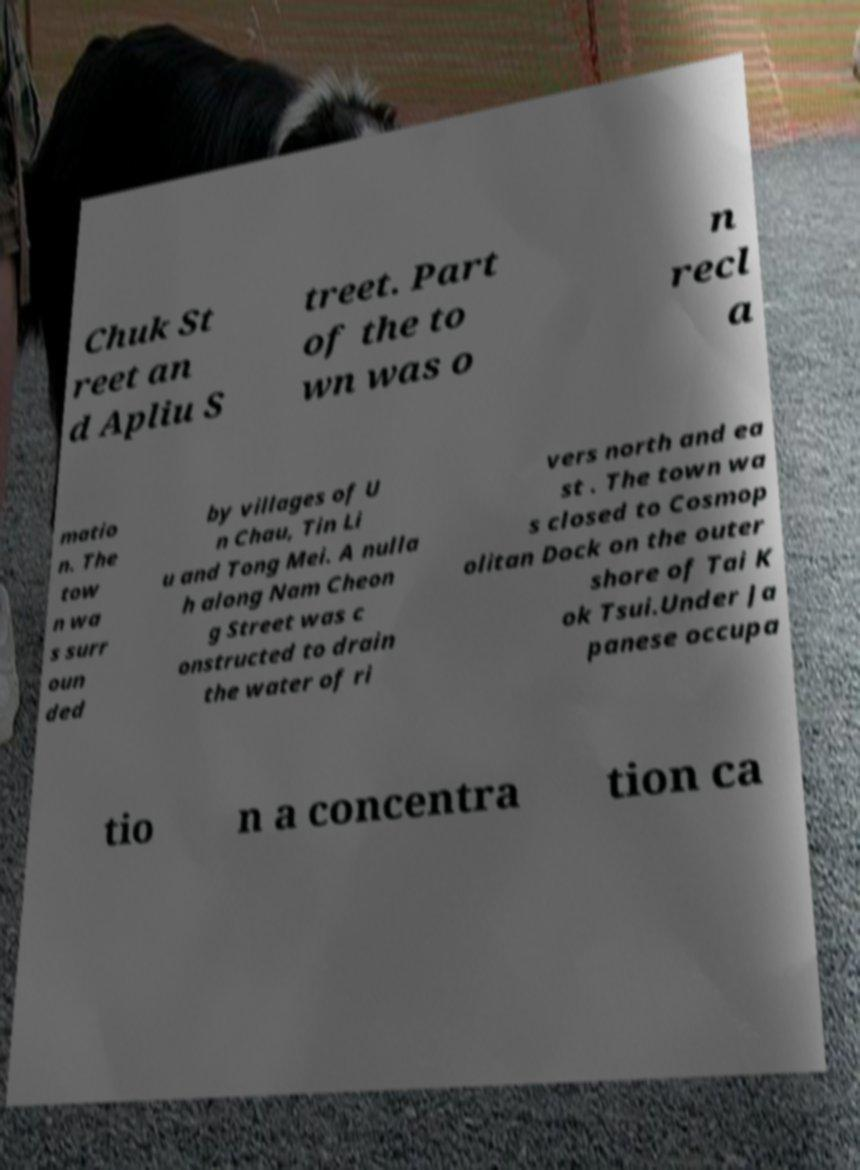For documentation purposes, I need the text within this image transcribed. Could you provide that? Chuk St reet an d Apliu S treet. Part of the to wn was o n recl a matio n. The tow n wa s surr oun ded by villages of U n Chau, Tin Li u and Tong Mei. A nulla h along Nam Cheon g Street was c onstructed to drain the water of ri vers north and ea st . The town wa s closed to Cosmop olitan Dock on the outer shore of Tai K ok Tsui.Under Ja panese occupa tio n a concentra tion ca 